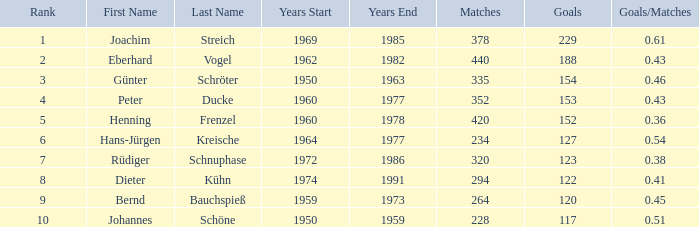Which years had 440 matches and less than 229 goals? 1962–1982. 